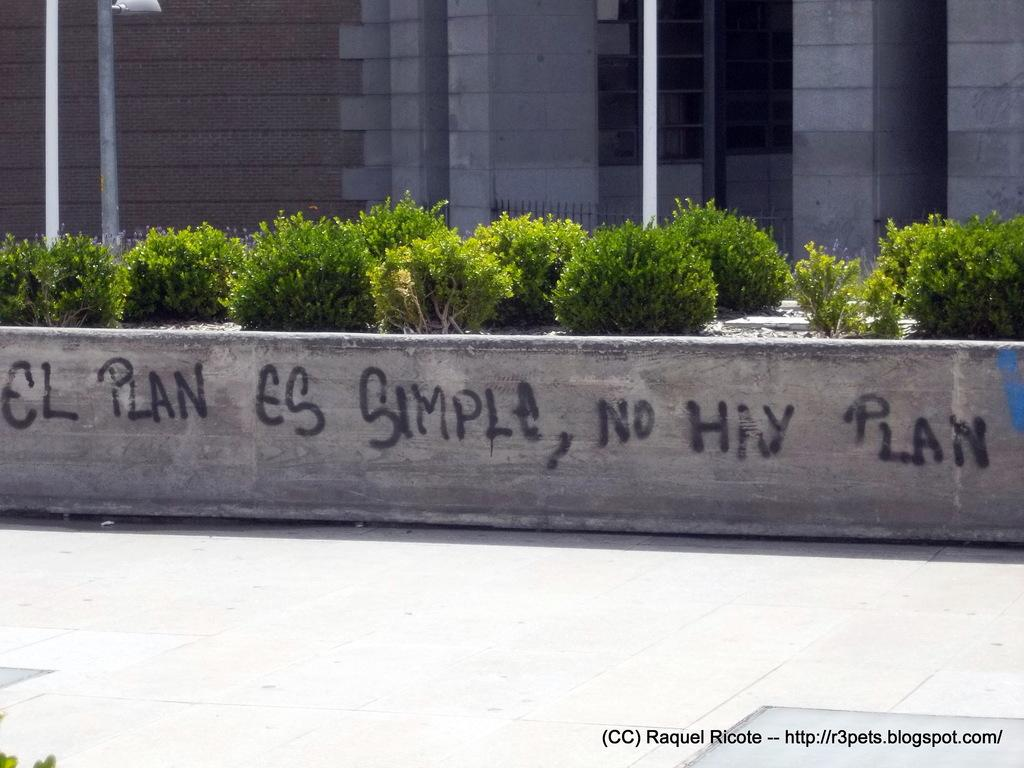What type of structure is visible in the image? There is a building in the image. What can be seen in the foreground of the image? There are plants in the foreground of the image. What else is present in the image besides the building and plants? There are poles in the image. Can you describe any text visible in the image? There is text on the wall of the building and at the bottom right of the image. What type of wealth is being displayed in the image? There is no indication of wealth being displayed in the image; it features a building, plants, poles, and text. What type of songs can be heard in the image? There is no audio component in the image, so it is not possible to determine what songs might be heard. 